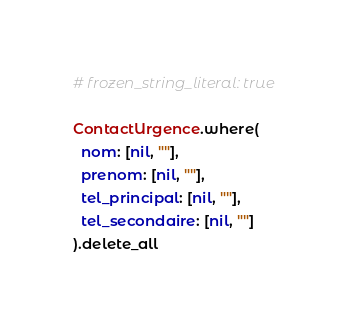<code> <loc_0><loc_0><loc_500><loc_500><_Ruby_># frozen_string_literal: true

ContactUrgence.where(
  nom: [nil, ""],
  prenom: [nil, ""],
  tel_principal: [nil, ""],
  tel_secondaire: [nil, ""]
).delete_all
</code> 